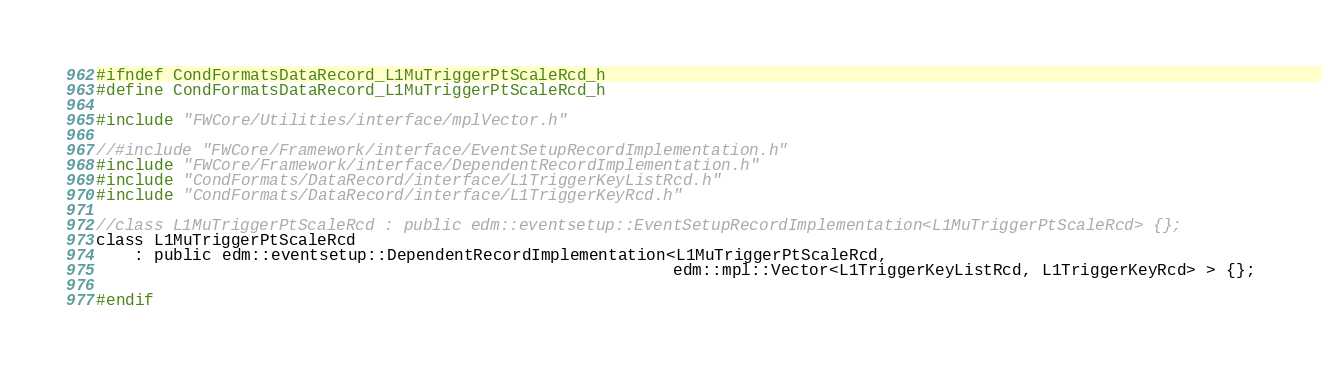<code> <loc_0><loc_0><loc_500><loc_500><_C_>#ifndef CondFormatsDataRecord_L1MuTriggerPtScaleRcd_h
#define CondFormatsDataRecord_L1MuTriggerPtScaleRcd_h

#include "FWCore/Utilities/interface/mplVector.h"

//#include "FWCore/Framework/interface/EventSetupRecordImplementation.h"
#include "FWCore/Framework/interface/DependentRecordImplementation.h"
#include "CondFormats/DataRecord/interface/L1TriggerKeyListRcd.h"
#include "CondFormats/DataRecord/interface/L1TriggerKeyRcd.h"

//class L1MuTriggerPtScaleRcd : public edm::eventsetup::EventSetupRecordImplementation<L1MuTriggerPtScaleRcd> {};
class L1MuTriggerPtScaleRcd
    : public edm::eventsetup::DependentRecordImplementation<L1MuTriggerPtScaleRcd,
                                                            edm::mpl::Vector<L1TriggerKeyListRcd, L1TriggerKeyRcd> > {};

#endif
</code> 